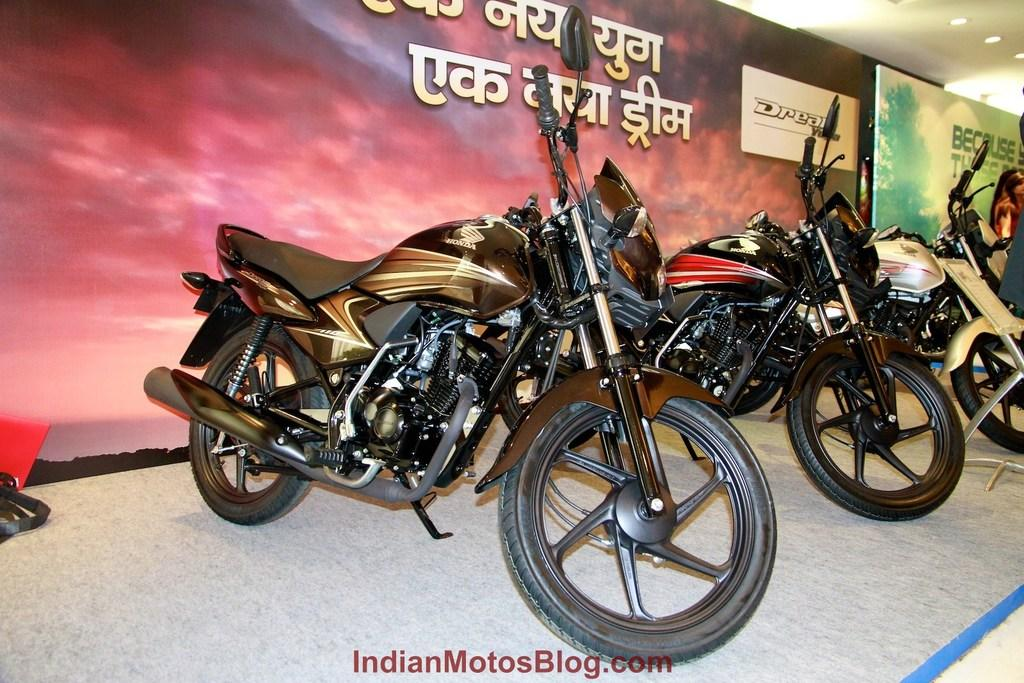What type of vehicles are in the image? There are black color motorcycles in the image. What else can be seen in the image besides the motorcycles? There are banners in the image. What is written on the banners? There is matter written on the banners. What is visible at the top of the image? There are lights at the top of the image. How many bulbs are attached to the body of the motorcycles in the image? There is no mention of bulbs or any attachment to the motorcycles in the image. Can you see a ticket on any of the motorcycles in the image? There is no ticket visible on any of the motorcycles in the image. 